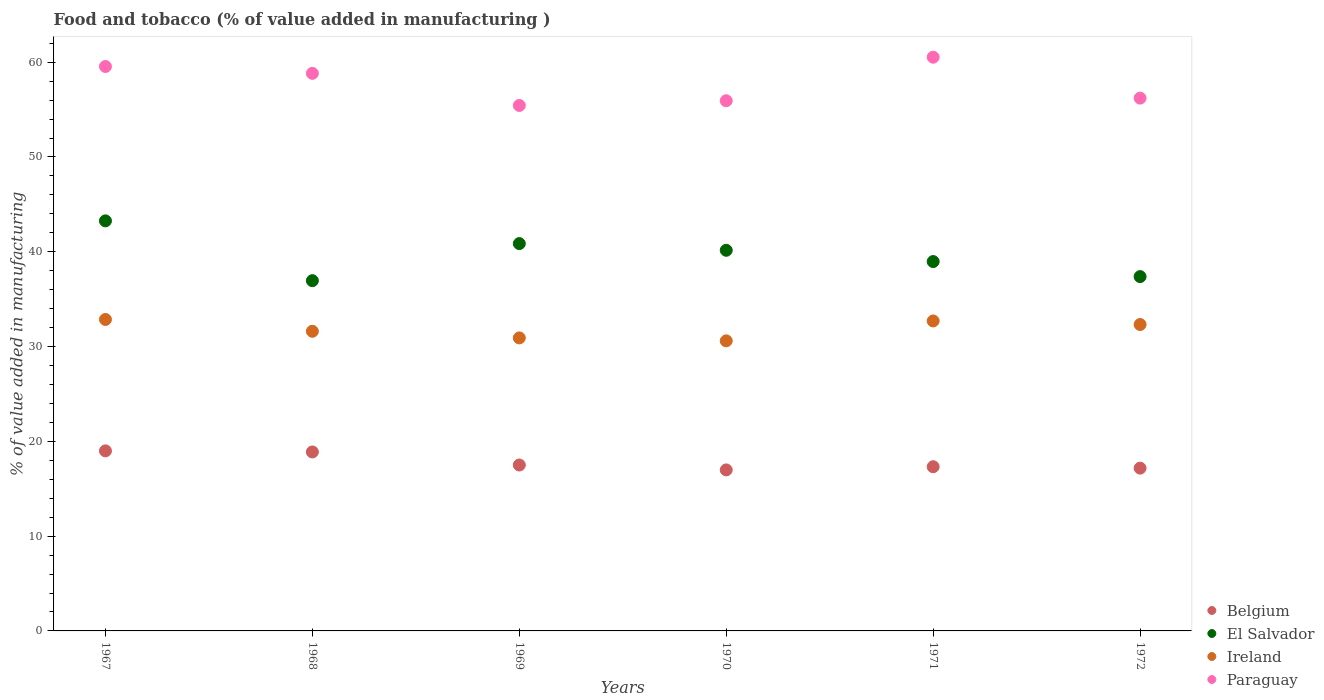What is the value added in manufacturing food and tobacco in Paraguay in 1969?
Provide a succinct answer. 55.44. Across all years, what is the maximum value added in manufacturing food and tobacco in Belgium?
Your answer should be very brief. 19. Across all years, what is the minimum value added in manufacturing food and tobacco in Paraguay?
Provide a succinct answer. 55.44. In which year was the value added in manufacturing food and tobacco in Belgium maximum?
Offer a very short reply. 1967. What is the total value added in manufacturing food and tobacco in Ireland in the graph?
Provide a short and direct response. 191.02. What is the difference between the value added in manufacturing food and tobacco in Ireland in 1971 and that in 1972?
Offer a very short reply. 0.38. What is the difference between the value added in manufacturing food and tobacco in Ireland in 1972 and the value added in manufacturing food and tobacco in El Salvador in 1970?
Your response must be concise. -7.83. What is the average value added in manufacturing food and tobacco in Ireland per year?
Keep it short and to the point. 31.84. In the year 1969, what is the difference between the value added in manufacturing food and tobacco in Ireland and value added in manufacturing food and tobacco in Paraguay?
Offer a very short reply. -24.52. In how many years, is the value added in manufacturing food and tobacco in Ireland greater than 36 %?
Ensure brevity in your answer.  0. What is the ratio of the value added in manufacturing food and tobacco in Paraguay in 1967 to that in 1972?
Offer a very short reply. 1.06. Is the difference between the value added in manufacturing food and tobacco in Ireland in 1968 and 1972 greater than the difference between the value added in manufacturing food and tobacco in Paraguay in 1968 and 1972?
Give a very brief answer. No. What is the difference between the highest and the second highest value added in manufacturing food and tobacco in Ireland?
Offer a very short reply. 0.16. What is the difference between the highest and the lowest value added in manufacturing food and tobacco in Belgium?
Provide a short and direct response. 2.01. Does the value added in manufacturing food and tobacco in Paraguay monotonically increase over the years?
Your answer should be very brief. No. Are the values on the major ticks of Y-axis written in scientific E-notation?
Your answer should be compact. No. Does the graph contain any zero values?
Ensure brevity in your answer.  No. Does the graph contain grids?
Make the answer very short. No. Where does the legend appear in the graph?
Ensure brevity in your answer.  Bottom right. What is the title of the graph?
Offer a terse response. Food and tobacco (% of value added in manufacturing ). What is the label or title of the Y-axis?
Keep it short and to the point. % of value added in manufacturing. What is the % of value added in manufacturing in Belgium in 1967?
Give a very brief answer. 19. What is the % of value added in manufacturing in El Salvador in 1967?
Offer a terse response. 43.26. What is the % of value added in manufacturing of Ireland in 1967?
Make the answer very short. 32.86. What is the % of value added in manufacturing of Paraguay in 1967?
Provide a succinct answer. 59.55. What is the % of value added in manufacturing of Belgium in 1968?
Give a very brief answer. 18.88. What is the % of value added in manufacturing in El Salvador in 1968?
Your answer should be very brief. 36.95. What is the % of value added in manufacturing of Ireland in 1968?
Offer a very short reply. 31.61. What is the % of value added in manufacturing of Paraguay in 1968?
Offer a terse response. 58.82. What is the % of value added in manufacturing in Belgium in 1969?
Offer a very short reply. 17.5. What is the % of value added in manufacturing in El Salvador in 1969?
Keep it short and to the point. 40.86. What is the % of value added in manufacturing in Ireland in 1969?
Your answer should be very brief. 30.91. What is the % of value added in manufacturing of Paraguay in 1969?
Give a very brief answer. 55.44. What is the % of value added in manufacturing of Belgium in 1970?
Your answer should be compact. 16.99. What is the % of value added in manufacturing in El Salvador in 1970?
Make the answer very short. 40.16. What is the % of value added in manufacturing in Ireland in 1970?
Keep it short and to the point. 30.6. What is the % of value added in manufacturing of Paraguay in 1970?
Make the answer very short. 55.93. What is the % of value added in manufacturing of Belgium in 1971?
Ensure brevity in your answer.  17.32. What is the % of value added in manufacturing in El Salvador in 1971?
Ensure brevity in your answer.  38.97. What is the % of value added in manufacturing in Ireland in 1971?
Your response must be concise. 32.7. What is the % of value added in manufacturing of Paraguay in 1971?
Give a very brief answer. 60.53. What is the % of value added in manufacturing in Belgium in 1972?
Your answer should be very brief. 17.17. What is the % of value added in manufacturing in El Salvador in 1972?
Provide a short and direct response. 37.38. What is the % of value added in manufacturing of Ireland in 1972?
Your answer should be very brief. 32.33. What is the % of value added in manufacturing in Paraguay in 1972?
Give a very brief answer. 56.21. Across all years, what is the maximum % of value added in manufacturing in Belgium?
Make the answer very short. 19. Across all years, what is the maximum % of value added in manufacturing in El Salvador?
Your answer should be compact. 43.26. Across all years, what is the maximum % of value added in manufacturing in Ireland?
Give a very brief answer. 32.86. Across all years, what is the maximum % of value added in manufacturing of Paraguay?
Your answer should be compact. 60.53. Across all years, what is the minimum % of value added in manufacturing of Belgium?
Provide a short and direct response. 16.99. Across all years, what is the minimum % of value added in manufacturing in El Salvador?
Make the answer very short. 36.95. Across all years, what is the minimum % of value added in manufacturing in Ireland?
Ensure brevity in your answer.  30.6. Across all years, what is the minimum % of value added in manufacturing of Paraguay?
Provide a short and direct response. 55.44. What is the total % of value added in manufacturing in Belgium in the graph?
Provide a succinct answer. 106.86. What is the total % of value added in manufacturing in El Salvador in the graph?
Provide a succinct answer. 237.59. What is the total % of value added in manufacturing of Ireland in the graph?
Your answer should be compact. 191.02. What is the total % of value added in manufacturing in Paraguay in the graph?
Your response must be concise. 346.48. What is the difference between the % of value added in manufacturing of Belgium in 1967 and that in 1968?
Keep it short and to the point. 0.11. What is the difference between the % of value added in manufacturing in El Salvador in 1967 and that in 1968?
Your answer should be very brief. 6.31. What is the difference between the % of value added in manufacturing of Ireland in 1967 and that in 1968?
Keep it short and to the point. 1.25. What is the difference between the % of value added in manufacturing of Paraguay in 1967 and that in 1968?
Keep it short and to the point. 0.72. What is the difference between the % of value added in manufacturing in Belgium in 1967 and that in 1969?
Provide a succinct answer. 1.49. What is the difference between the % of value added in manufacturing of El Salvador in 1967 and that in 1969?
Make the answer very short. 2.4. What is the difference between the % of value added in manufacturing of Ireland in 1967 and that in 1969?
Your answer should be very brief. 1.95. What is the difference between the % of value added in manufacturing of Paraguay in 1967 and that in 1969?
Give a very brief answer. 4.11. What is the difference between the % of value added in manufacturing in Belgium in 1967 and that in 1970?
Your answer should be compact. 2.01. What is the difference between the % of value added in manufacturing of El Salvador in 1967 and that in 1970?
Keep it short and to the point. 3.1. What is the difference between the % of value added in manufacturing of Ireland in 1967 and that in 1970?
Keep it short and to the point. 2.26. What is the difference between the % of value added in manufacturing in Paraguay in 1967 and that in 1970?
Your answer should be very brief. 3.61. What is the difference between the % of value added in manufacturing in Belgium in 1967 and that in 1971?
Offer a terse response. 1.67. What is the difference between the % of value added in manufacturing of El Salvador in 1967 and that in 1971?
Offer a very short reply. 4.29. What is the difference between the % of value added in manufacturing in Ireland in 1967 and that in 1971?
Provide a short and direct response. 0.16. What is the difference between the % of value added in manufacturing in Paraguay in 1967 and that in 1971?
Keep it short and to the point. -0.98. What is the difference between the % of value added in manufacturing of Belgium in 1967 and that in 1972?
Offer a terse response. 1.82. What is the difference between the % of value added in manufacturing in El Salvador in 1967 and that in 1972?
Ensure brevity in your answer.  5.88. What is the difference between the % of value added in manufacturing of Ireland in 1967 and that in 1972?
Provide a short and direct response. 0.53. What is the difference between the % of value added in manufacturing of Paraguay in 1967 and that in 1972?
Make the answer very short. 3.34. What is the difference between the % of value added in manufacturing in Belgium in 1968 and that in 1969?
Your answer should be compact. 1.38. What is the difference between the % of value added in manufacturing in El Salvador in 1968 and that in 1969?
Provide a short and direct response. -3.91. What is the difference between the % of value added in manufacturing in Ireland in 1968 and that in 1969?
Your answer should be very brief. 0.7. What is the difference between the % of value added in manufacturing of Paraguay in 1968 and that in 1969?
Provide a short and direct response. 3.39. What is the difference between the % of value added in manufacturing of Belgium in 1968 and that in 1970?
Ensure brevity in your answer.  1.89. What is the difference between the % of value added in manufacturing of El Salvador in 1968 and that in 1970?
Offer a very short reply. -3.21. What is the difference between the % of value added in manufacturing of Ireland in 1968 and that in 1970?
Your response must be concise. 1.01. What is the difference between the % of value added in manufacturing of Paraguay in 1968 and that in 1970?
Your answer should be compact. 2.89. What is the difference between the % of value added in manufacturing in Belgium in 1968 and that in 1971?
Offer a terse response. 1.56. What is the difference between the % of value added in manufacturing in El Salvador in 1968 and that in 1971?
Ensure brevity in your answer.  -2.02. What is the difference between the % of value added in manufacturing of Ireland in 1968 and that in 1971?
Keep it short and to the point. -1.09. What is the difference between the % of value added in manufacturing in Paraguay in 1968 and that in 1971?
Make the answer very short. -1.7. What is the difference between the % of value added in manufacturing in Belgium in 1968 and that in 1972?
Ensure brevity in your answer.  1.71. What is the difference between the % of value added in manufacturing in El Salvador in 1968 and that in 1972?
Your answer should be very brief. -0.43. What is the difference between the % of value added in manufacturing in Ireland in 1968 and that in 1972?
Keep it short and to the point. -0.71. What is the difference between the % of value added in manufacturing of Paraguay in 1968 and that in 1972?
Make the answer very short. 2.61. What is the difference between the % of value added in manufacturing of Belgium in 1969 and that in 1970?
Offer a terse response. 0.52. What is the difference between the % of value added in manufacturing in El Salvador in 1969 and that in 1970?
Your answer should be compact. 0.71. What is the difference between the % of value added in manufacturing of Ireland in 1969 and that in 1970?
Offer a terse response. 0.31. What is the difference between the % of value added in manufacturing in Paraguay in 1969 and that in 1970?
Give a very brief answer. -0.5. What is the difference between the % of value added in manufacturing in Belgium in 1969 and that in 1971?
Your response must be concise. 0.18. What is the difference between the % of value added in manufacturing in El Salvador in 1969 and that in 1971?
Ensure brevity in your answer.  1.89. What is the difference between the % of value added in manufacturing of Ireland in 1969 and that in 1971?
Your answer should be very brief. -1.79. What is the difference between the % of value added in manufacturing in Paraguay in 1969 and that in 1971?
Ensure brevity in your answer.  -5.09. What is the difference between the % of value added in manufacturing in Belgium in 1969 and that in 1972?
Provide a short and direct response. 0.33. What is the difference between the % of value added in manufacturing of El Salvador in 1969 and that in 1972?
Ensure brevity in your answer.  3.48. What is the difference between the % of value added in manufacturing of Ireland in 1969 and that in 1972?
Offer a terse response. -1.41. What is the difference between the % of value added in manufacturing of Paraguay in 1969 and that in 1972?
Provide a short and direct response. -0.77. What is the difference between the % of value added in manufacturing in Belgium in 1970 and that in 1971?
Your response must be concise. -0.34. What is the difference between the % of value added in manufacturing in El Salvador in 1970 and that in 1971?
Your answer should be compact. 1.19. What is the difference between the % of value added in manufacturing of Ireland in 1970 and that in 1971?
Ensure brevity in your answer.  -2.1. What is the difference between the % of value added in manufacturing in Paraguay in 1970 and that in 1971?
Offer a very short reply. -4.59. What is the difference between the % of value added in manufacturing of Belgium in 1970 and that in 1972?
Offer a very short reply. -0.19. What is the difference between the % of value added in manufacturing of El Salvador in 1970 and that in 1972?
Your answer should be compact. 2.78. What is the difference between the % of value added in manufacturing in Ireland in 1970 and that in 1972?
Offer a terse response. -1.72. What is the difference between the % of value added in manufacturing in Paraguay in 1970 and that in 1972?
Offer a terse response. -0.28. What is the difference between the % of value added in manufacturing in Belgium in 1971 and that in 1972?
Your answer should be compact. 0.15. What is the difference between the % of value added in manufacturing in El Salvador in 1971 and that in 1972?
Make the answer very short. 1.59. What is the difference between the % of value added in manufacturing of Ireland in 1971 and that in 1972?
Make the answer very short. 0.38. What is the difference between the % of value added in manufacturing of Paraguay in 1971 and that in 1972?
Give a very brief answer. 4.32. What is the difference between the % of value added in manufacturing in Belgium in 1967 and the % of value added in manufacturing in El Salvador in 1968?
Make the answer very short. -17.96. What is the difference between the % of value added in manufacturing of Belgium in 1967 and the % of value added in manufacturing of Ireland in 1968?
Offer a very short reply. -12.62. What is the difference between the % of value added in manufacturing in Belgium in 1967 and the % of value added in manufacturing in Paraguay in 1968?
Your answer should be compact. -39.83. What is the difference between the % of value added in manufacturing of El Salvador in 1967 and the % of value added in manufacturing of Ireland in 1968?
Your answer should be very brief. 11.65. What is the difference between the % of value added in manufacturing in El Salvador in 1967 and the % of value added in manufacturing in Paraguay in 1968?
Your response must be concise. -15.56. What is the difference between the % of value added in manufacturing in Ireland in 1967 and the % of value added in manufacturing in Paraguay in 1968?
Your answer should be very brief. -25.97. What is the difference between the % of value added in manufacturing in Belgium in 1967 and the % of value added in manufacturing in El Salvador in 1969?
Your response must be concise. -21.87. What is the difference between the % of value added in manufacturing of Belgium in 1967 and the % of value added in manufacturing of Ireland in 1969?
Your response must be concise. -11.92. What is the difference between the % of value added in manufacturing in Belgium in 1967 and the % of value added in manufacturing in Paraguay in 1969?
Ensure brevity in your answer.  -36.44. What is the difference between the % of value added in manufacturing of El Salvador in 1967 and the % of value added in manufacturing of Ireland in 1969?
Your response must be concise. 12.35. What is the difference between the % of value added in manufacturing of El Salvador in 1967 and the % of value added in manufacturing of Paraguay in 1969?
Your response must be concise. -12.18. What is the difference between the % of value added in manufacturing in Ireland in 1967 and the % of value added in manufacturing in Paraguay in 1969?
Keep it short and to the point. -22.58. What is the difference between the % of value added in manufacturing of Belgium in 1967 and the % of value added in manufacturing of El Salvador in 1970?
Offer a very short reply. -21.16. What is the difference between the % of value added in manufacturing of Belgium in 1967 and the % of value added in manufacturing of Ireland in 1970?
Your response must be concise. -11.61. What is the difference between the % of value added in manufacturing of Belgium in 1967 and the % of value added in manufacturing of Paraguay in 1970?
Keep it short and to the point. -36.94. What is the difference between the % of value added in manufacturing in El Salvador in 1967 and the % of value added in manufacturing in Ireland in 1970?
Make the answer very short. 12.66. What is the difference between the % of value added in manufacturing of El Salvador in 1967 and the % of value added in manufacturing of Paraguay in 1970?
Offer a terse response. -12.67. What is the difference between the % of value added in manufacturing of Ireland in 1967 and the % of value added in manufacturing of Paraguay in 1970?
Give a very brief answer. -23.07. What is the difference between the % of value added in manufacturing of Belgium in 1967 and the % of value added in manufacturing of El Salvador in 1971?
Offer a terse response. -19.97. What is the difference between the % of value added in manufacturing of Belgium in 1967 and the % of value added in manufacturing of Ireland in 1971?
Offer a very short reply. -13.71. What is the difference between the % of value added in manufacturing in Belgium in 1967 and the % of value added in manufacturing in Paraguay in 1971?
Provide a short and direct response. -41.53. What is the difference between the % of value added in manufacturing in El Salvador in 1967 and the % of value added in manufacturing in Ireland in 1971?
Keep it short and to the point. 10.56. What is the difference between the % of value added in manufacturing of El Salvador in 1967 and the % of value added in manufacturing of Paraguay in 1971?
Your response must be concise. -17.27. What is the difference between the % of value added in manufacturing in Ireland in 1967 and the % of value added in manufacturing in Paraguay in 1971?
Offer a terse response. -27.67. What is the difference between the % of value added in manufacturing of Belgium in 1967 and the % of value added in manufacturing of El Salvador in 1972?
Make the answer very short. -18.39. What is the difference between the % of value added in manufacturing of Belgium in 1967 and the % of value added in manufacturing of Ireland in 1972?
Keep it short and to the point. -13.33. What is the difference between the % of value added in manufacturing of Belgium in 1967 and the % of value added in manufacturing of Paraguay in 1972?
Your response must be concise. -37.22. What is the difference between the % of value added in manufacturing in El Salvador in 1967 and the % of value added in manufacturing in Ireland in 1972?
Offer a terse response. 10.94. What is the difference between the % of value added in manufacturing of El Salvador in 1967 and the % of value added in manufacturing of Paraguay in 1972?
Your answer should be very brief. -12.95. What is the difference between the % of value added in manufacturing in Ireland in 1967 and the % of value added in manufacturing in Paraguay in 1972?
Provide a short and direct response. -23.35. What is the difference between the % of value added in manufacturing of Belgium in 1968 and the % of value added in manufacturing of El Salvador in 1969?
Provide a short and direct response. -21.98. What is the difference between the % of value added in manufacturing in Belgium in 1968 and the % of value added in manufacturing in Ireland in 1969?
Offer a very short reply. -12.03. What is the difference between the % of value added in manufacturing in Belgium in 1968 and the % of value added in manufacturing in Paraguay in 1969?
Your answer should be very brief. -36.56. What is the difference between the % of value added in manufacturing of El Salvador in 1968 and the % of value added in manufacturing of Ireland in 1969?
Offer a terse response. 6.04. What is the difference between the % of value added in manufacturing of El Salvador in 1968 and the % of value added in manufacturing of Paraguay in 1969?
Offer a very short reply. -18.49. What is the difference between the % of value added in manufacturing of Ireland in 1968 and the % of value added in manufacturing of Paraguay in 1969?
Provide a succinct answer. -23.83. What is the difference between the % of value added in manufacturing of Belgium in 1968 and the % of value added in manufacturing of El Salvador in 1970?
Your response must be concise. -21.28. What is the difference between the % of value added in manufacturing of Belgium in 1968 and the % of value added in manufacturing of Ireland in 1970?
Keep it short and to the point. -11.72. What is the difference between the % of value added in manufacturing in Belgium in 1968 and the % of value added in manufacturing in Paraguay in 1970?
Your answer should be very brief. -37.05. What is the difference between the % of value added in manufacturing of El Salvador in 1968 and the % of value added in manufacturing of Ireland in 1970?
Give a very brief answer. 6.35. What is the difference between the % of value added in manufacturing of El Salvador in 1968 and the % of value added in manufacturing of Paraguay in 1970?
Your answer should be compact. -18.98. What is the difference between the % of value added in manufacturing in Ireland in 1968 and the % of value added in manufacturing in Paraguay in 1970?
Your answer should be very brief. -24.32. What is the difference between the % of value added in manufacturing of Belgium in 1968 and the % of value added in manufacturing of El Salvador in 1971?
Offer a very short reply. -20.09. What is the difference between the % of value added in manufacturing in Belgium in 1968 and the % of value added in manufacturing in Ireland in 1971?
Provide a succinct answer. -13.82. What is the difference between the % of value added in manufacturing in Belgium in 1968 and the % of value added in manufacturing in Paraguay in 1971?
Give a very brief answer. -41.65. What is the difference between the % of value added in manufacturing of El Salvador in 1968 and the % of value added in manufacturing of Ireland in 1971?
Your response must be concise. 4.25. What is the difference between the % of value added in manufacturing in El Salvador in 1968 and the % of value added in manufacturing in Paraguay in 1971?
Make the answer very short. -23.58. What is the difference between the % of value added in manufacturing of Ireland in 1968 and the % of value added in manufacturing of Paraguay in 1971?
Provide a short and direct response. -28.92. What is the difference between the % of value added in manufacturing in Belgium in 1968 and the % of value added in manufacturing in El Salvador in 1972?
Your answer should be compact. -18.5. What is the difference between the % of value added in manufacturing in Belgium in 1968 and the % of value added in manufacturing in Ireland in 1972?
Make the answer very short. -13.45. What is the difference between the % of value added in manufacturing of Belgium in 1968 and the % of value added in manufacturing of Paraguay in 1972?
Offer a very short reply. -37.33. What is the difference between the % of value added in manufacturing in El Salvador in 1968 and the % of value added in manufacturing in Ireland in 1972?
Ensure brevity in your answer.  4.63. What is the difference between the % of value added in manufacturing of El Salvador in 1968 and the % of value added in manufacturing of Paraguay in 1972?
Your answer should be very brief. -19.26. What is the difference between the % of value added in manufacturing of Ireland in 1968 and the % of value added in manufacturing of Paraguay in 1972?
Ensure brevity in your answer.  -24.6. What is the difference between the % of value added in manufacturing of Belgium in 1969 and the % of value added in manufacturing of El Salvador in 1970?
Your answer should be very brief. -22.65. What is the difference between the % of value added in manufacturing in Belgium in 1969 and the % of value added in manufacturing in Ireland in 1970?
Give a very brief answer. -13.1. What is the difference between the % of value added in manufacturing of Belgium in 1969 and the % of value added in manufacturing of Paraguay in 1970?
Provide a short and direct response. -38.43. What is the difference between the % of value added in manufacturing in El Salvador in 1969 and the % of value added in manufacturing in Ireland in 1970?
Your answer should be compact. 10.26. What is the difference between the % of value added in manufacturing of El Salvador in 1969 and the % of value added in manufacturing of Paraguay in 1970?
Provide a short and direct response. -15.07. What is the difference between the % of value added in manufacturing of Ireland in 1969 and the % of value added in manufacturing of Paraguay in 1970?
Make the answer very short. -25.02. What is the difference between the % of value added in manufacturing of Belgium in 1969 and the % of value added in manufacturing of El Salvador in 1971?
Offer a terse response. -21.47. What is the difference between the % of value added in manufacturing in Belgium in 1969 and the % of value added in manufacturing in Ireland in 1971?
Your response must be concise. -15.2. What is the difference between the % of value added in manufacturing of Belgium in 1969 and the % of value added in manufacturing of Paraguay in 1971?
Make the answer very short. -43.02. What is the difference between the % of value added in manufacturing of El Salvador in 1969 and the % of value added in manufacturing of Ireland in 1971?
Provide a short and direct response. 8.16. What is the difference between the % of value added in manufacturing in El Salvador in 1969 and the % of value added in manufacturing in Paraguay in 1971?
Give a very brief answer. -19.66. What is the difference between the % of value added in manufacturing of Ireland in 1969 and the % of value added in manufacturing of Paraguay in 1971?
Make the answer very short. -29.61. What is the difference between the % of value added in manufacturing in Belgium in 1969 and the % of value added in manufacturing in El Salvador in 1972?
Give a very brief answer. -19.88. What is the difference between the % of value added in manufacturing of Belgium in 1969 and the % of value added in manufacturing of Ireland in 1972?
Offer a terse response. -14.82. What is the difference between the % of value added in manufacturing in Belgium in 1969 and the % of value added in manufacturing in Paraguay in 1972?
Ensure brevity in your answer.  -38.71. What is the difference between the % of value added in manufacturing of El Salvador in 1969 and the % of value added in manufacturing of Ireland in 1972?
Offer a very short reply. 8.54. What is the difference between the % of value added in manufacturing in El Salvador in 1969 and the % of value added in manufacturing in Paraguay in 1972?
Provide a succinct answer. -15.35. What is the difference between the % of value added in manufacturing in Ireland in 1969 and the % of value added in manufacturing in Paraguay in 1972?
Give a very brief answer. -25.3. What is the difference between the % of value added in manufacturing of Belgium in 1970 and the % of value added in manufacturing of El Salvador in 1971?
Offer a terse response. -21.98. What is the difference between the % of value added in manufacturing in Belgium in 1970 and the % of value added in manufacturing in Ireland in 1971?
Give a very brief answer. -15.72. What is the difference between the % of value added in manufacturing of Belgium in 1970 and the % of value added in manufacturing of Paraguay in 1971?
Your answer should be compact. -43.54. What is the difference between the % of value added in manufacturing of El Salvador in 1970 and the % of value added in manufacturing of Ireland in 1971?
Offer a terse response. 7.45. What is the difference between the % of value added in manufacturing of El Salvador in 1970 and the % of value added in manufacturing of Paraguay in 1971?
Ensure brevity in your answer.  -20.37. What is the difference between the % of value added in manufacturing of Ireland in 1970 and the % of value added in manufacturing of Paraguay in 1971?
Offer a very short reply. -29.92. What is the difference between the % of value added in manufacturing of Belgium in 1970 and the % of value added in manufacturing of El Salvador in 1972?
Make the answer very short. -20.39. What is the difference between the % of value added in manufacturing of Belgium in 1970 and the % of value added in manufacturing of Ireland in 1972?
Give a very brief answer. -15.34. What is the difference between the % of value added in manufacturing in Belgium in 1970 and the % of value added in manufacturing in Paraguay in 1972?
Offer a very short reply. -39.22. What is the difference between the % of value added in manufacturing in El Salvador in 1970 and the % of value added in manufacturing in Ireland in 1972?
Ensure brevity in your answer.  7.83. What is the difference between the % of value added in manufacturing in El Salvador in 1970 and the % of value added in manufacturing in Paraguay in 1972?
Make the answer very short. -16.05. What is the difference between the % of value added in manufacturing in Ireland in 1970 and the % of value added in manufacturing in Paraguay in 1972?
Make the answer very short. -25.61. What is the difference between the % of value added in manufacturing of Belgium in 1971 and the % of value added in manufacturing of El Salvador in 1972?
Offer a very short reply. -20.06. What is the difference between the % of value added in manufacturing of Belgium in 1971 and the % of value added in manufacturing of Ireland in 1972?
Provide a short and direct response. -15. What is the difference between the % of value added in manufacturing in Belgium in 1971 and the % of value added in manufacturing in Paraguay in 1972?
Your response must be concise. -38.89. What is the difference between the % of value added in manufacturing of El Salvador in 1971 and the % of value added in manufacturing of Ireland in 1972?
Offer a terse response. 6.64. What is the difference between the % of value added in manufacturing of El Salvador in 1971 and the % of value added in manufacturing of Paraguay in 1972?
Provide a short and direct response. -17.24. What is the difference between the % of value added in manufacturing of Ireland in 1971 and the % of value added in manufacturing of Paraguay in 1972?
Make the answer very short. -23.51. What is the average % of value added in manufacturing in Belgium per year?
Your answer should be compact. 17.81. What is the average % of value added in manufacturing in El Salvador per year?
Your answer should be very brief. 39.6. What is the average % of value added in manufacturing of Ireland per year?
Provide a short and direct response. 31.84. What is the average % of value added in manufacturing of Paraguay per year?
Offer a very short reply. 57.75. In the year 1967, what is the difference between the % of value added in manufacturing of Belgium and % of value added in manufacturing of El Salvador?
Your answer should be very brief. -24.27. In the year 1967, what is the difference between the % of value added in manufacturing of Belgium and % of value added in manufacturing of Ireland?
Give a very brief answer. -13.86. In the year 1967, what is the difference between the % of value added in manufacturing of Belgium and % of value added in manufacturing of Paraguay?
Keep it short and to the point. -40.55. In the year 1967, what is the difference between the % of value added in manufacturing in El Salvador and % of value added in manufacturing in Ireland?
Make the answer very short. 10.4. In the year 1967, what is the difference between the % of value added in manufacturing of El Salvador and % of value added in manufacturing of Paraguay?
Your answer should be very brief. -16.29. In the year 1967, what is the difference between the % of value added in manufacturing of Ireland and % of value added in manufacturing of Paraguay?
Offer a very short reply. -26.69. In the year 1968, what is the difference between the % of value added in manufacturing in Belgium and % of value added in manufacturing in El Salvador?
Make the answer very short. -18.07. In the year 1968, what is the difference between the % of value added in manufacturing in Belgium and % of value added in manufacturing in Ireland?
Provide a short and direct response. -12.73. In the year 1968, what is the difference between the % of value added in manufacturing of Belgium and % of value added in manufacturing of Paraguay?
Make the answer very short. -39.94. In the year 1968, what is the difference between the % of value added in manufacturing of El Salvador and % of value added in manufacturing of Ireland?
Your answer should be compact. 5.34. In the year 1968, what is the difference between the % of value added in manufacturing of El Salvador and % of value added in manufacturing of Paraguay?
Make the answer very short. -21.87. In the year 1968, what is the difference between the % of value added in manufacturing in Ireland and % of value added in manufacturing in Paraguay?
Offer a very short reply. -27.21. In the year 1969, what is the difference between the % of value added in manufacturing in Belgium and % of value added in manufacturing in El Salvador?
Offer a very short reply. -23.36. In the year 1969, what is the difference between the % of value added in manufacturing of Belgium and % of value added in manufacturing of Ireland?
Give a very brief answer. -13.41. In the year 1969, what is the difference between the % of value added in manufacturing of Belgium and % of value added in manufacturing of Paraguay?
Offer a very short reply. -37.93. In the year 1969, what is the difference between the % of value added in manufacturing of El Salvador and % of value added in manufacturing of Ireland?
Offer a terse response. 9.95. In the year 1969, what is the difference between the % of value added in manufacturing in El Salvador and % of value added in manufacturing in Paraguay?
Provide a short and direct response. -14.57. In the year 1969, what is the difference between the % of value added in manufacturing of Ireland and % of value added in manufacturing of Paraguay?
Offer a very short reply. -24.52. In the year 1970, what is the difference between the % of value added in manufacturing in Belgium and % of value added in manufacturing in El Salvador?
Your answer should be very brief. -23.17. In the year 1970, what is the difference between the % of value added in manufacturing of Belgium and % of value added in manufacturing of Ireland?
Your answer should be compact. -13.62. In the year 1970, what is the difference between the % of value added in manufacturing in Belgium and % of value added in manufacturing in Paraguay?
Your answer should be very brief. -38.95. In the year 1970, what is the difference between the % of value added in manufacturing of El Salvador and % of value added in manufacturing of Ireland?
Provide a short and direct response. 9.55. In the year 1970, what is the difference between the % of value added in manufacturing in El Salvador and % of value added in manufacturing in Paraguay?
Keep it short and to the point. -15.78. In the year 1970, what is the difference between the % of value added in manufacturing in Ireland and % of value added in manufacturing in Paraguay?
Your response must be concise. -25.33. In the year 1971, what is the difference between the % of value added in manufacturing in Belgium and % of value added in manufacturing in El Salvador?
Keep it short and to the point. -21.65. In the year 1971, what is the difference between the % of value added in manufacturing of Belgium and % of value added in manufacturing of Ireland?
Provide a succinct answer. -15.38. In the year 1971, what is the difference between the % of value added in manufacturing of Belgium and % of value added in manufacturing of Paraguay?
Your answer should be very brief. -43.2. In the year 1971, what is the difference between the % of value added in manufacturing of El Salvador and % of value added in manufacturing of Ireland?
Keep it short and to the point. 6.27. In the year 1971, what is the difference between the % of value added in manufacturing in El Salvador and % of value added in manufacturing in Paraguay?
Your response must be concise. -21.56. In the year 1971, what is the difference between the % of value added in manufacturing of Ireland and % of value added in manufacturing of Paraguay?
Your response must be concise. -27.82. In the year 1972, what is the difference between the % of value added in manufacturing in Belgium and % of value added in manufacturing in El Salvador?
Offer a terse response. -20.21. In the year 1972, what is the difference between the % of value added in manufacturing of Belgium and % of value added in manufacturing of Ireland?
Your response must be concise. -15.15. In the year 1972, what is the difference between the % of value added in manufacturing in Belgium and % of value added in manufacturing in Paraguay?
Make the answer very short. -39.04. In the year 1972, what is the difference between the % of value added in manufacturing of El Salvador and % of value added in manufacturing of Ireland?
Provide a succinct answer. 5.06. In the year 1972, what is the difference between the % of value added in manufacturing of El Salvador and % of value added in manufacturing of Paraguay?
Your answer should be compact. -18.83. In the year 1972, what is the difference between the % of value added in manufacturing of Ireland and % of value added in manufacturing of Paraguay?
Your answer should be very brief. -23.88. What is the ratio of the % of value added in manufacturing in El Salvador in 1967 to that in 1968?
Your answer should be very brief. 1.17. What is the ratio of the % of value added in manufacturing of Ireland in 1967 to that in 1968?
Keep it short and to the point. 1.04. What is the ratio of the % of value added in manufacturing in Paraguay in 1967 to that in 1968?
Give a very brief answer. 1.01. What is the ratio of the % of value added in manufacturing of Belgium in 1967 to that in 1969?
Ensure brevity in your answer.  1.09. What is the ratio of the % of value added in manufacturing in El Salvador in 1967 to that in 1969?
Your answer should be compact. 1.06. What is the ratio of the % of value added in manufacturing of Ireland in 1967 to that in 1969?
Offer a very short reply. 1.06. What is the ratio of the % of value added in manufacturing of Paraguay in 1967 to that in 1969?
Offer a terse response. 1.07. What is the ratio of the % of value added in manufacturing in Belgium in 1967 to that in 1970?
Ensure brevity in your answer.  1.12. What is the ratio of the % of value added in manufacturing in El Salvador in 1967 to that in 1970?
Make the answer very short. 1.08. What is the ratio of the % of value added in manufacturing of Ireland in 1967 to that in 1970?
Keep it short and to the point. 1.07. What is the ratio of the % of value added in manufacturing in Paraguay in 1967 to that in 1970?
Offer a terse response. 1.06. What is the ratio of the % of value added in manufacturing in Belgium in 1967 to that in 1971?
Offer a terse response. 1.1. What is the ratio of the % of value added in manufacturing of El Salvador in 1967 to that in 1971?
Provide a short and direct response. 1.11. What is the ratio of the % of value added in manufacturing in Ireland in 1967 to that in 1971?
Ensure brevity in your answer.  1. What is the ratio of the % of value added in manufacturing in Paraguay in 1967 to that in 1971?
Provide a short and direct response. 0.98. What is the ratio of the % of value added in manufacturing in Belgium in 1967 to that in 1972?
Your response must be concise. 1.11. What is the ratio of the % of value added in manufacturing in El Salvador in 1967 to that in 1972?
Your answer should be compact. 1.16. What is the ratio of the % of value added in manufacturing of Ireland in 1967 to that in 1972?
Provide a short and direct response. 1.02. What is the ratio of the % of value added in manufacturing in Paraguay in 1967 to that in 1972?
Make the answer very short. 1.06. What is the ratio of the % of value added in manufacturing in Belgium in 1968 to that in 1969?
Provide a short and direct response. 1.08. What is the ratio of the % of value added in manufacturing of El Salvador in 1968 to that in 1969?
Ensure brevity in your answer.  0.9. What is the ratio of the % of value added in manufacturing in Ireland in 1968 to that in 1969?
Ensure brevity in your answer.  1.02. What is the ratio of the % of value added in manufacturing in Paraguay in 1968 to that in 1969?
Provide a short and direct response. 1.06. What is the ratio of the % of value added in manufacturing in Belgium in 1968 to that in 1970?
Your answer should be compact. 1.11. What is the ratio of the % of value added in manufacturing in El Salvador in 1968 to that in 1970?
Ensure brevity in your answer.  0.92. What is the ratio of the % of value added in manufacturing in Ireland in 1968 to that in 1970?
Provide a short and direct response. 1.03. What is the ratio of the % of value added in manufacturing in Paraguay in 1968 to that in 1970?
Provide a short and direct response. 1.05. What is the ratio of the % of value added in manufacturing of Belgium in 1968 to that in 1971?
Your answer should be compact. 1.09. What is the ratio of the % of value added in manufacturing of El Salvador in 1968 to that in 1971?
Offer a terse response. 0.95. What is the ratio of the % of value added in manufacturing in Ireland in 1968 to that in 1971?
Make the answer very short. 0.97. What is the ratio of the % of value added in manufacturing of Paraguay in 1968 to that in 1971?
Provide a succinct answer. 0.97. What is the ratio of the % of value added in manufacturing in Belgium in 1968 to that in 1972?
Your answer should be compact. 1.1. What is the ratio of the % of value added in manufacturing in Ireland in 1968 to that in 1972?
Provide a short and direct response. 0.98. What is the ratio of the % of value added in manufacturing in Paraguay in 1968 to that in 1972?
Provide a succinct answer. 1.05. What is the ratio of the % of value added in manufacturing of Belgium in 1969 to that in 1970?
Keep it short and to the point. 1.03. What is the ratio of the % of value added in manufacturing of El Salvador in 1969 to that in 1970?
Offer a terse response. 1.02. What is the ratio of the % of value added in manufacturing in Ireland in 1969 to that in 1970?
Keep it short and to the point. 1.01. What is the ratio of the % of value added in manufacturing of Belgium in 1969 to that in 1971?
Ensure brevity in your answer.  1.01. What is the ratio of the % of value added in manufacturing in El Salvador in 1969 to that in 1971?
Give a very brief answer. 1.05. What is the ratio of the % of value added in manufacturing of Ireland in 1969 to that in 1971?
Keep it short and to the point. 0.95. What is the ratio of the % of value added in manufacturing of Paraguay in 1969 to that in 1971?
Your answer should be very brief. 0.92. What is the ratio of the % of value added in manufacturing in Belgium in 1969 to that in 1972?
Keep it short and to the point. 1.02. What is the ratio of the % of value added in manufacturing of El Salvador in 1969 to that in 1972?
Give a very brief answer. 1.09. What is the ratio of the % of value added in manufacturing in Ireland in 1969 to that in 1972?
Your answer should be compact. 0.96. What is the ratio of the % of value added in manufacturing in Paraguay in 1969 to that in 1972?
Your answer should be compact. 0.99. What is the ratio of the % of value added in manufacturing in Belgium in 1970 to that in 1971?
Keep it short and to the point. 0.98. What is the ratio of the % of value added in manufacturing of El Salvador in 1970 to that in 1971?
Offer a terse response. 1.03. What is the ratio of the % of value added in manufacturing in Ireland in 1970 to that in 1971?
Your answer should be very brief. 0.94. What is the ratio of the % of value added in manufacturing of Paraguay in 1970 to that in 1971?
Provide a short and direct response. 0.92. What is the ratio of the % of value added in manufacturing of El Salvador in 1970 to that in 1972?
Keep it short and to the point. 1.07. What is the ratio of the % of value added in manufacturing of Ireland in 1970 to that in 1972?
Make the answer very short. 0.95. What is the ratio of the % of value added in manufacturing of Paraguay in 1970 to that in 1972?
Make the answer very short. 1. What is the ratio of the % of value added in manufacturing of Belgium in 1971 to that in 1972?
Ensure brevity in your answer.  1.01. What is the ratio of the % of value added in manufacturing of El Salvador in 1971 to that in 1972?
Keep it short and to the point. 1.04. What is the ratio of the % of value added in manufacturing in Ireland in 1971 to that in 1972?
Give a very brief answer. 1.01. What is the ratio of the % of value added in manufacturing in Paraguay in 1971 to that in 1972?
Your answer should be compact. 1.08. What is the difference between the highest and the second highest % of value added in manufacturing of Belgium?
Offer a very short reply. 0.11. What is the difference between the highest and the second highest % of value added in manufacturing of El Salvador?
Your response must be concise. 2.4. What is the difference between the highest and the second highest % of value added in manufacturing in Ireland?
Give a very brief answer. 0.16. What is the difference between the highest and the second highest % of value added in manufacturing of Paraguay?
Your response must be concise. 0.98. What is the difference between the highest and the lowest % of value added in manufacturing in Belgium?
Ensure brevity in your answer.  2.01. What is the difference between the highest and the lowest % of value added in manufacturing in El Salvador?
Make the answer very short. 6.31. What is the difference between the highest and the lowest % of value added in manufacturing in Ireland?
Provide a short and direct response. 2.26. What is the difference between the highest and the lowest % of value added in manufacturing of Paraguay?
Give a very brief answer. 5.09. 